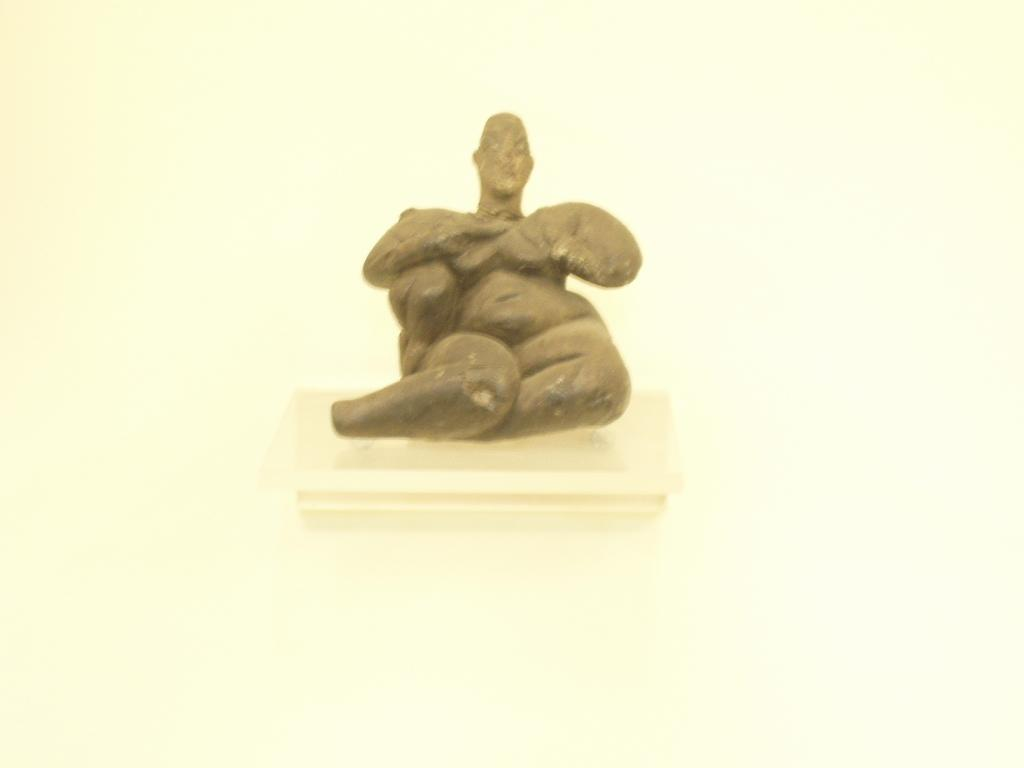What is placed on the floor in the image? There is an idol of a person on the floor in the image. Can you describe the idol in the image? The idol is of a person, and it is placed on the floor. What type of servant is attending to the idol in the image? There is no servant present in the image; it only shows an idol of a person placed on the floor. 